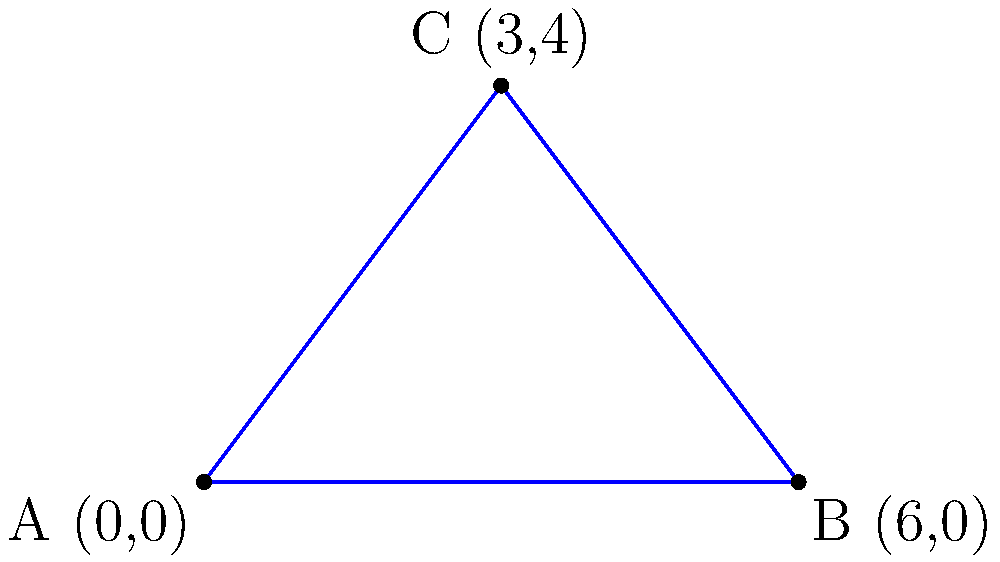At the Woodstock Revival Festival, a triangular stage is being set up. The coordinates of the stage's vertices are A(0,0), B(6,0), and C(3,4) in a coordinate system where each unit represents 10 meters. What is the area of this triangular stage in square meters? To find the area of the triangular stage, we can use the formula for the area of a triangle given the coordinates of its vertices:

Area = $\frac{1}{2}|x_1(y_2 - y_3) + x_2(y_3 - y_1) + x_3(y_1 - y_2)|$

Where $(x_1, y_1)$, $(x_2, y_2)$, and $(x_3, y_3)$ are the coordinates of the three vertices.

Step 1: Identify the coordinates
A: $(x_1, y_1) = (0, 0)$
B: $(x_2, y_2) = (6, 0)$
C: $(x_3, y_3) = (3, 4)$

Step 2: Substitute into the formula
Area = $\frac{1}{2}|0(0 - 4) + 6(4 - 0) + 3(0 - 0)|$

Step 3: Simplify
Area = $\frac{1}{2}|0 + 24 + 0|$
Area = $\frac{1}{2}(24)$
Area = 12

Step 4: Convert to square meters
Since each unit represents 10 meters, we need to multiply our result by $10^2 = 100$:

Area in square meters = $12 \times 100 = 1200$

Therefore, the area of the triangular stage is 1200 square meters.
Answer: 1200 square meters 